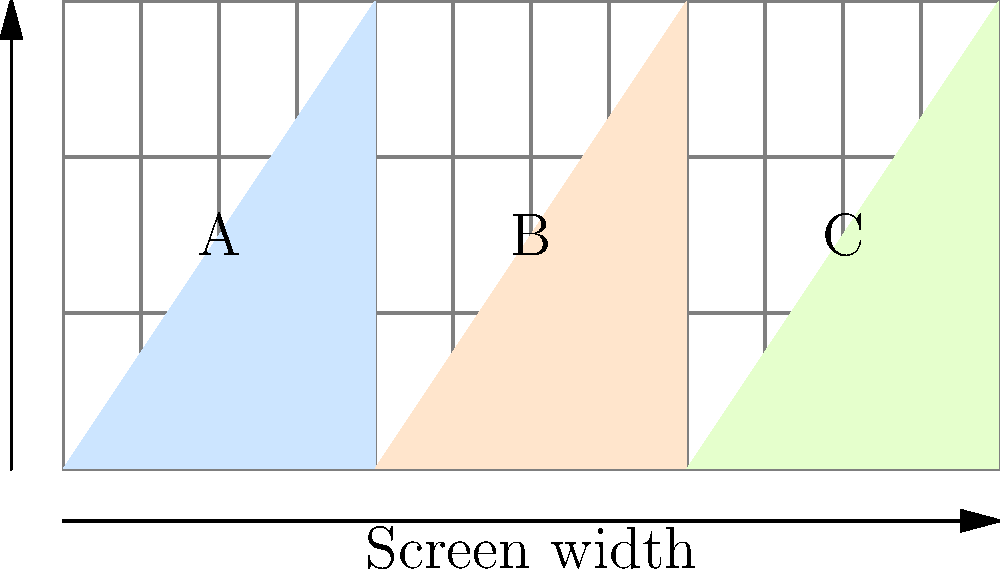In the responsive design grid shown above, three content sections (A, B, and C) are displayed using a 12-column layout. If the viewport width decreases to 768px, which is typically considered a tablet breakpoint, how should the layout be restructured to maintain optimal readability and usability? To optimize the layout for a tablet-sized viewport (768px), we need to consider the following steps:

1. Analyze the current layout:
   - Section A occupies 4 columns (33.33%)
   - Section B occupies 4 columns (33.33%)
   - Section C occupies 4 columns (33.33%)

2. Consider the principles of responsive design:
   - Maintain readability by ensuring content is not too cramped
   - Preserve a logical flow of information
   - Utilize the available space effectively

3. Adjust the layout for tablet viewport:
   - 768px is narrower than a typical desktop screen, so we need to stack some elements

4. Propose a new layout:
   - Section A: Expand to 6 columns (50%) to maintain prominence
   - Section B: Move below A, expand to 6 columns (50%)
   - Section C: Position next to B, occupying 6 columns (50%)

5. Resulting layout:
   ```
   [    A (6 cols)    ] [    A (6 cols)    ]
   [    B (6 cols)    ] [    C (6 cols)    ]
   ```

This layout ensures that:
- The main content (A) remains prominent and easy to read
- Secondary content (B and C) is still easily accessible
- The layout uses the full width of the tablet screen efficiently
- Content reflows in a logical order (A -> B -> C)
Answer: Stack B and C below A; A spans full width, B and C each 50% width 